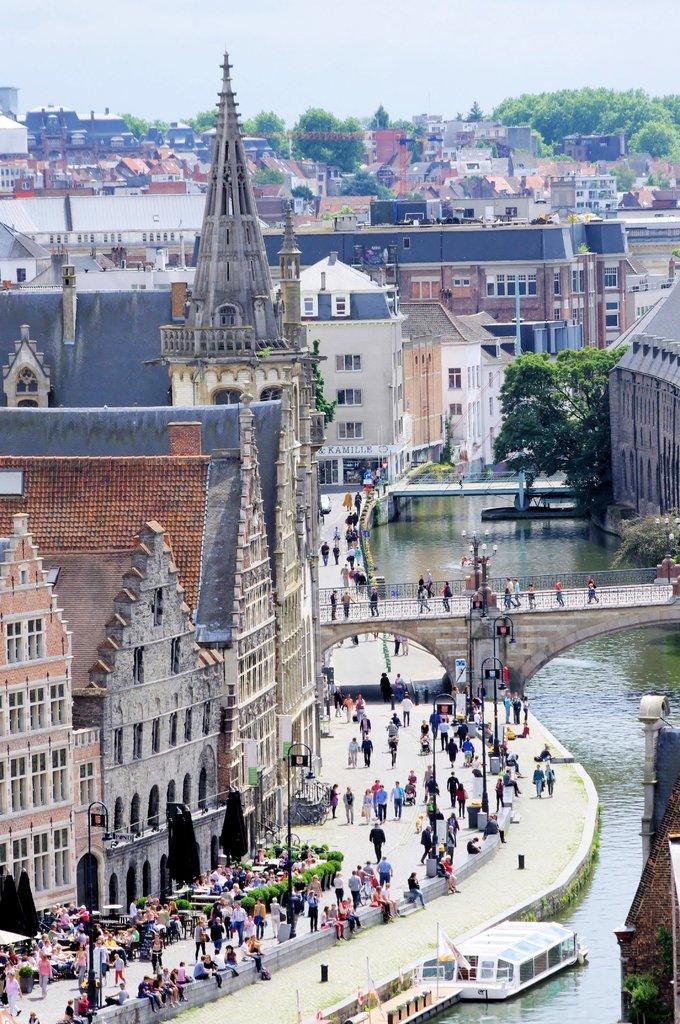Can you describe this image briefly? In this image in front there is a church and in front of the church people walking on the road. At the center of the image there are two boats in the water. On the backside there are trees, buildings and sky. We can see a bridge in the center of the image. 